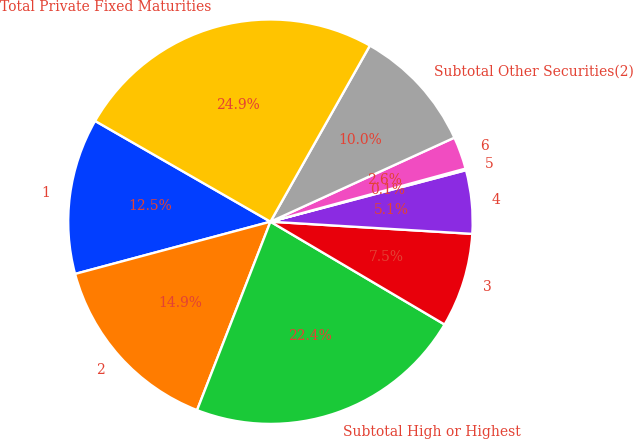<chart> <loc_0><loc_0><loc_500><loc_500><pie_chart><fcel>1<fcel>2<fcel>Subtotal High or Highest<fcel>3<fcel>4<fcel>5<fcel>6<fcel>Subtotal Other Securities(2)<fcel>Total Private Fixed Maturities<nl><fcel>12.46%<fcel>14.93%<fcel>22.42%<fcel>7.53%<fcel>5.06%<fcel>0.13%<fcel>2.59%<fcel>10.0%<fcel>24.88%<nl></chart> 